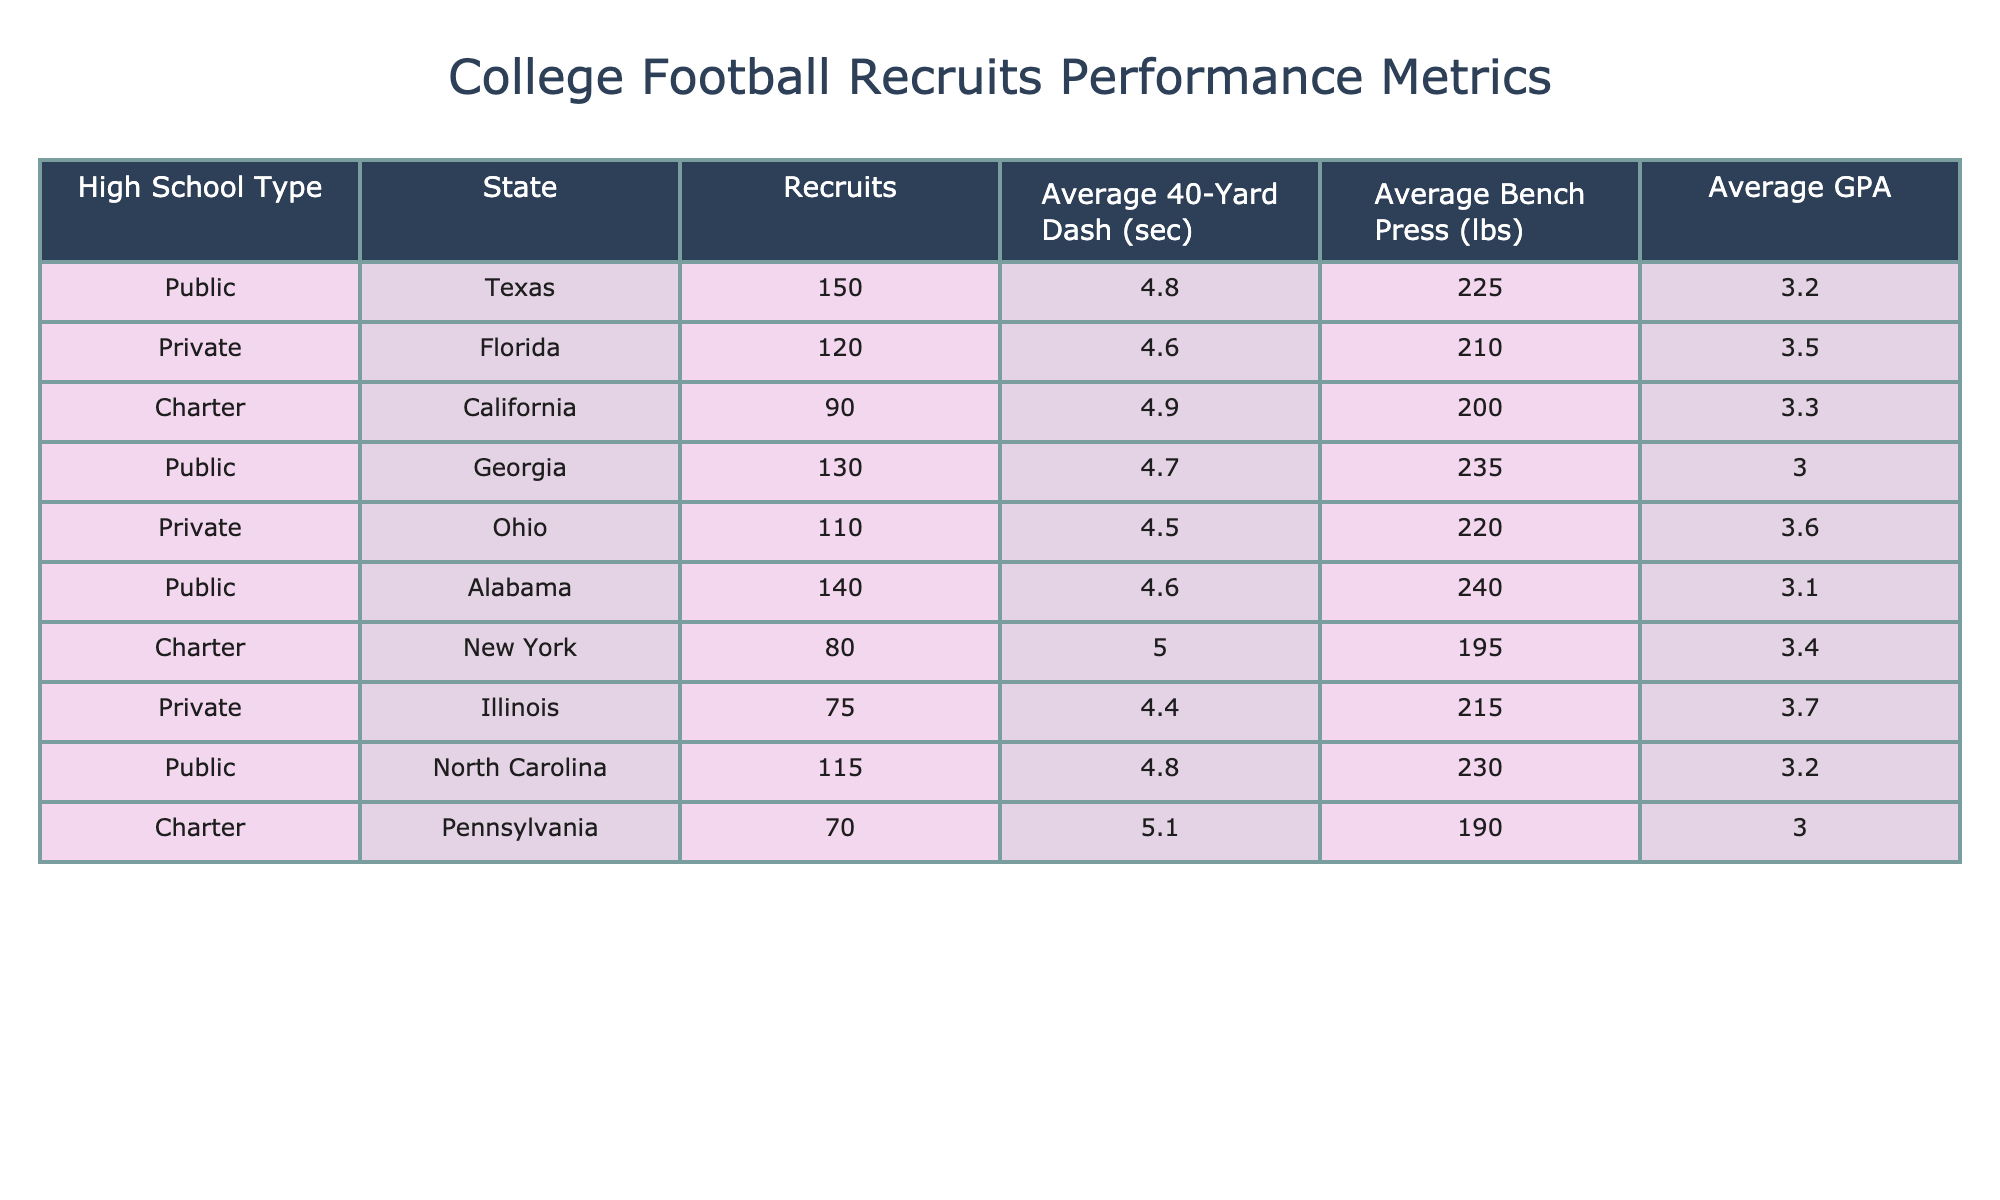What is the average GPA for recruits from Public schools? To find the average GPA for recruits from Public schools, I look at the GPA values associated with the rows labeled as Public. The GPAs are 3.2 (Texas), 3.0 (Georgia), 3.1 (Alabama), and 3.2 (North Carolina). There are four values, so the average GPA is calculated as (3.2 + 3.0 + 3.1 + 3.2) / 4 = 3.1375, which can be rounded to 3.14.
Answer: 3.14 Which state has the highest average bench press among Private school recruits? Inspecting the rows for Private school recruits, there are two states: Florida (210 lbs) and Ohio (220 lbs). Comparing these values, Ohio has the higher average bench press of 220 lbs.
Answer: Ohio Is the average 40-yard dash time for recruits from Charter schools less than 5 seconds? Looking at the 40-yard dash times for Charter schools, I see California (4.9 sec) and New York (5.0 sec). Both times are not less than 5 seconds, which means the average time is not less than 5 seconds.
Answer: No What is the difference in the average GPA between recruits from Private and Public schools? The average GPA for Private schools is calculated as (3.5 + 3.6 + 3.7) / 3 = 3.6133 (approximately 3.61). The average GPA for Public schools is 3.14 as calculated before. The difference is 3.61 - 3.14 = 0.47.
Answer: 0.47 How many recruits are there in total from Charter schools across all states? To find the total recruits from Charter schools, I check the number of recruits in California (90) and New York (80). Adding these together, 90 + 80 = 170 recruits from Charter schools.
Answer: 170 Which type of high school has the lowest average GPA and what is that GPA? Reviewing the average GPAs, for Public schools we calculated 3.14; for Private schools, I noted the average is approximately 3.61; for Charter, I compute (3.3 + 3.0) / 2 = 3.15. The lowest among these is from Public schools with 3.14.
Answer: Public schools, 3.14 Are there more recruits from the state of Texas than from the state of Ohio? Checking the recruits, Texas has 150 recruits while Ohio has 110 recruits. Since 150 is greater than 110, it confirms that there are more recruits from Texas than Ohio.
Answer: Yes What is the average 40-yard dash time for all recruits from the states of Florida and Alabama combined? The average 40-yard dash time involves the values from Florida (4.6 sec) and Alabama (4.6 sec). To calculate the average: (4.6 + 4.6) / 2 = 4.6 seconds for these two states.
Answer: 4.6 seconds Which high school type has the highest average 40-yard dash time and what is that time? I look at the average 40-yard dash times: Public (4.7), Private (4.6), Charter (4.95). The highest value among these belongs to Charter schools with 4.95 seconds.
Answer: Charter schools, 4.95 seconds 